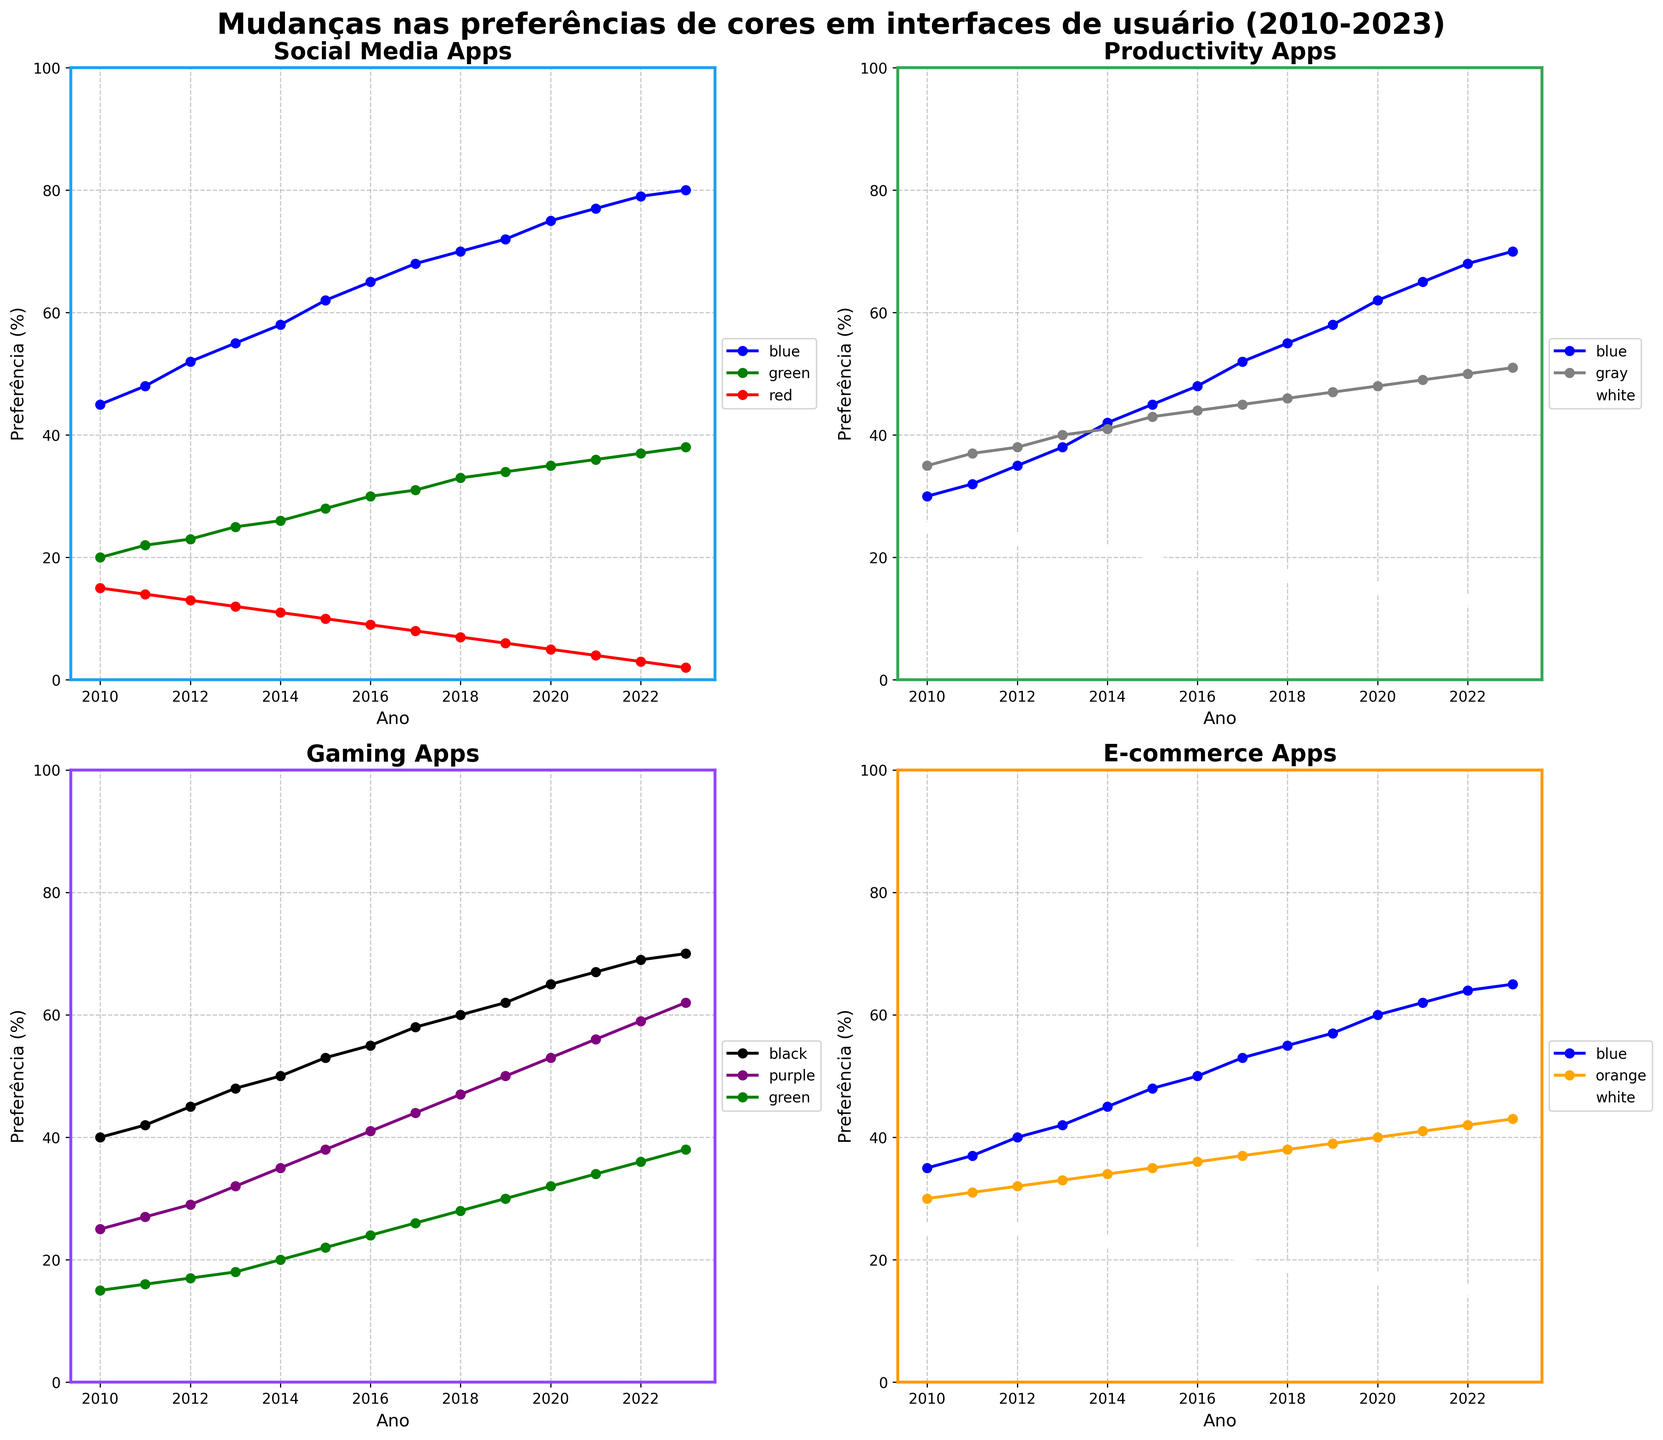Which color saw the most significant increase in preference for Social Media Apps over the years? Examine the plot for Social Media Apps. The "blue" line shows the largest increase from 45% in 2010 to 80% in 2023.
Answer: Blue What is the difference in preference between Blue and White for Productivity Apps in 2023? Look at the final data points for Blue and White in the Productivity Apps plot. Blue ends at 70%, and White at 12%. The difference is 70% - 12%.
Answer: 58% Which category shows a preference for the color Black, and how has it changed from 2010 to 2023? In the Gaming Apps plot, the color "Black" starts at 40% in 2010 and goes up to 70% in 2023.
Answer: Gaming Apps, +30% Compare the preference for Green in Social Media Apps and Gaming Apps in 2015. Which one is higher? Refer to the 2015 data points for Green in both Social Media Apps (10%) and Gaming Apps (22%). Gaming Apps has a higher preference for Green.
Answer: Gaming Apps On average, how did the preference for Gray in Productivity Apps change between 2010 and 2023? Calculate the average change by finding the average of the yearly changes in Gray's preference for Productivity Apps. This can be approximated by considering the overall increase from 35% in 2010 to 51% in 2023. Average change per year = (51% - 35%) / 13 ≈ 1.23% per year.
Answer: 1.23% per year Which E-commerce App color had the least preference change from 2010 to 2023? Look at the lines in the E-commerce plot. The "White" color shows the least change from 25% in 2010 to 14% in 2023.
Answer: White What is the rate of change in preference for Purple in Gaming Apps from 2010 to 2023? Calculate the rate of change by taking the difference in percentages for Purple from 2010 (25%) to 2023 (62%), divided by the number of years (2023 - 2010 = 13). Rate of change = (62% - 25%) / 13 ≈ 2.85% per year.
Answer: 2.85% per year How did the preference for Orange in E-commerce Apps change from 2010 to 2023? Refer to the plot for E-commerce Apps. The "Orange" color increases from 30% in 2010 to 43% in 2023.
Answer: +13% Compare the preference trends between Blue in Social Media Apps and Blue in E-commerce Apps. Which one shows a stronger upward trend? By examining both plots, the Blue line in Social Media Apps shows a stronger increase from 45% to 80% over the years compared to E-commerce Apps' increase from 35% to 65%.
Answer: Social Media Apps 